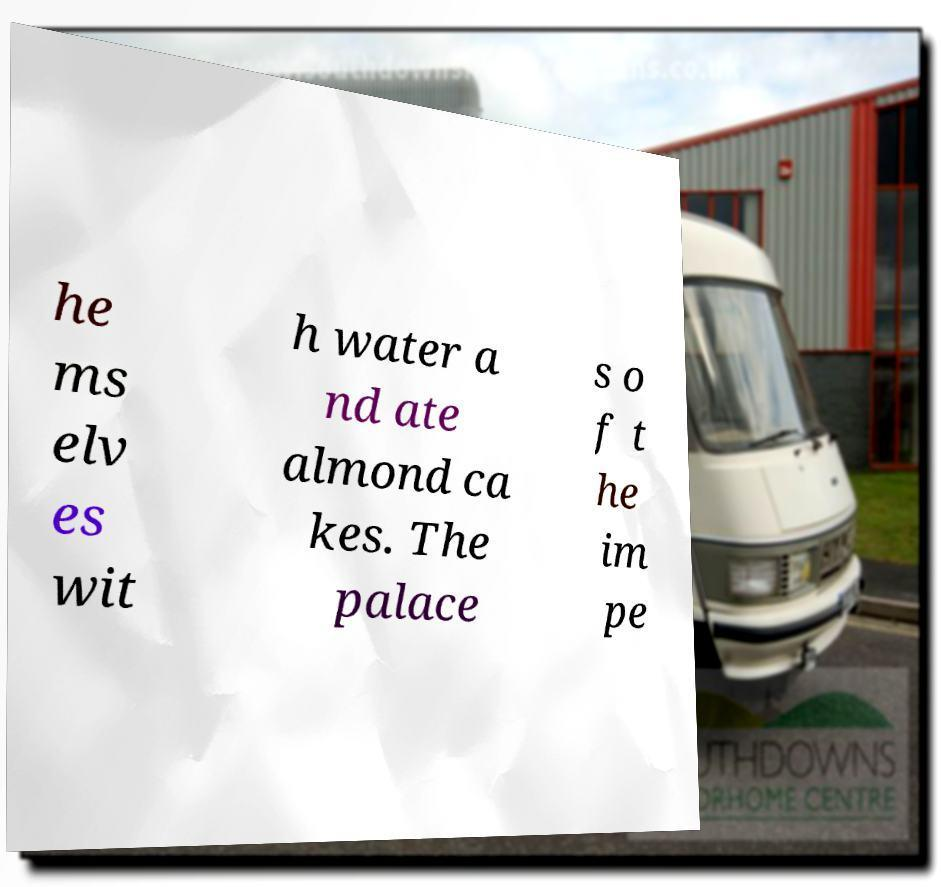Could you extract and type out the text from this image? he ms elv es wit h water a nd ate almond ca kes. The palace s o f t he im pe 